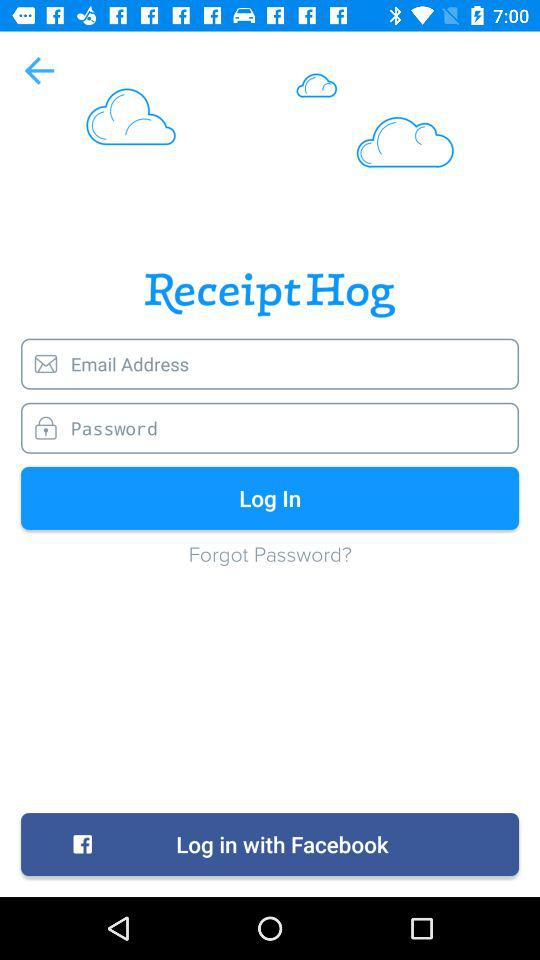How many clouds are on the screen?
Answer the question using a single word or phrase. 3 